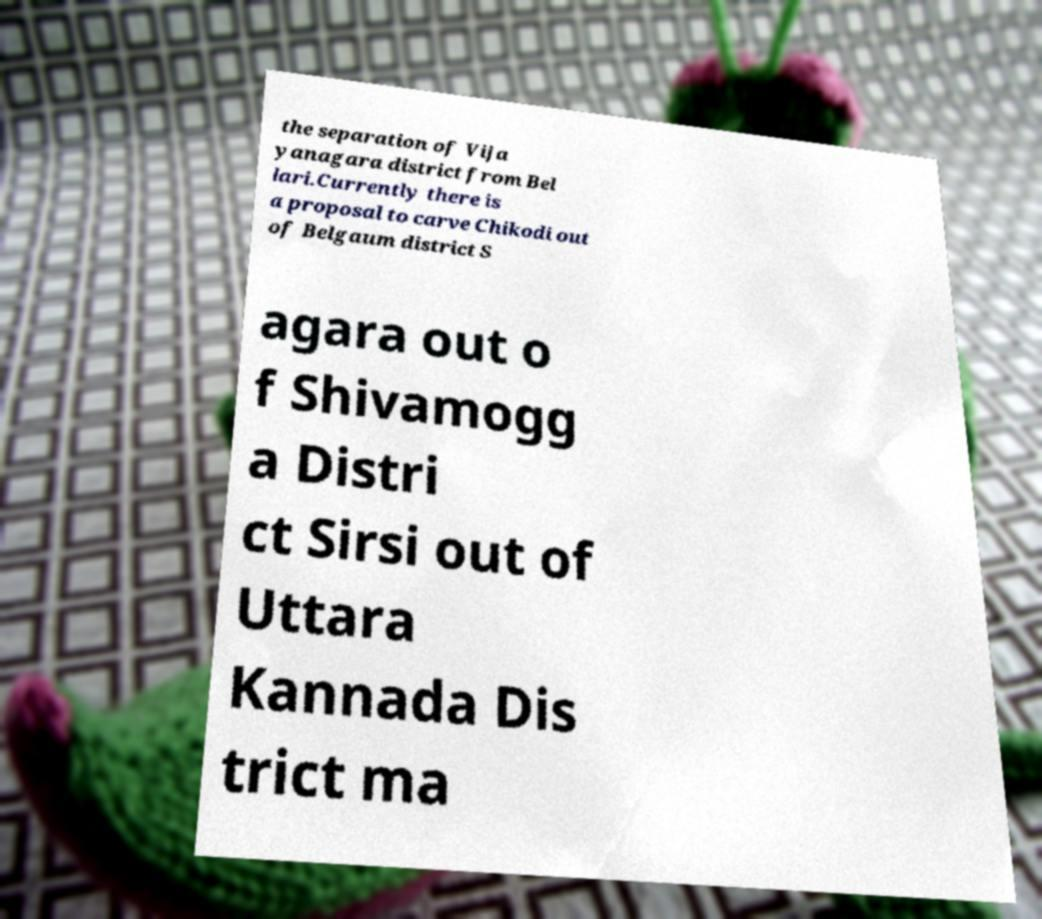There's text embedded in this image that I need extracted. Can you transcribe it verbatim? the separation of Vija yanagara district from Bel lari.Currently there is a proposal to carve Chikodi out of Belgaum district S agara out o f Shivamogg a Distri ct Sirsi out of Uttara Kannada Dis trict ma 